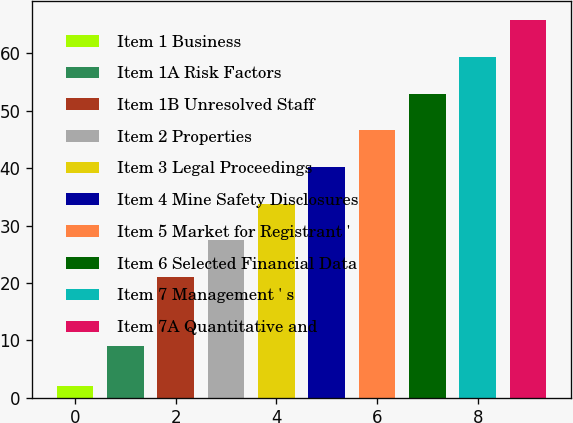Convert chart to OTSL. <chart><loc_0><loc_0><loc_500><loc_500><bar_chart><fcel>Item 1 Business<fcel>Item 1A Risk Factors<fcel>Item 1B Unresolved Staff<fcel>Item 2 Properties<fcel>Item 3 Legal Proceedings<fcel>Item 4 Mine Safety Disclosures<fcel>Item 5 Market for Registrant '<fcel>Item 6 Selected Financial Data<fcel>Item 7 Management ' s<fcel>Item 7A Quantitative and<nl><fcel>2<fcel>9<fcel>21<fcel>27.4<fcel>33.8<fcel>40.2<fcel>46.6<fcel>53<fcel>59.4<fcel>65.8<nl></chart> 